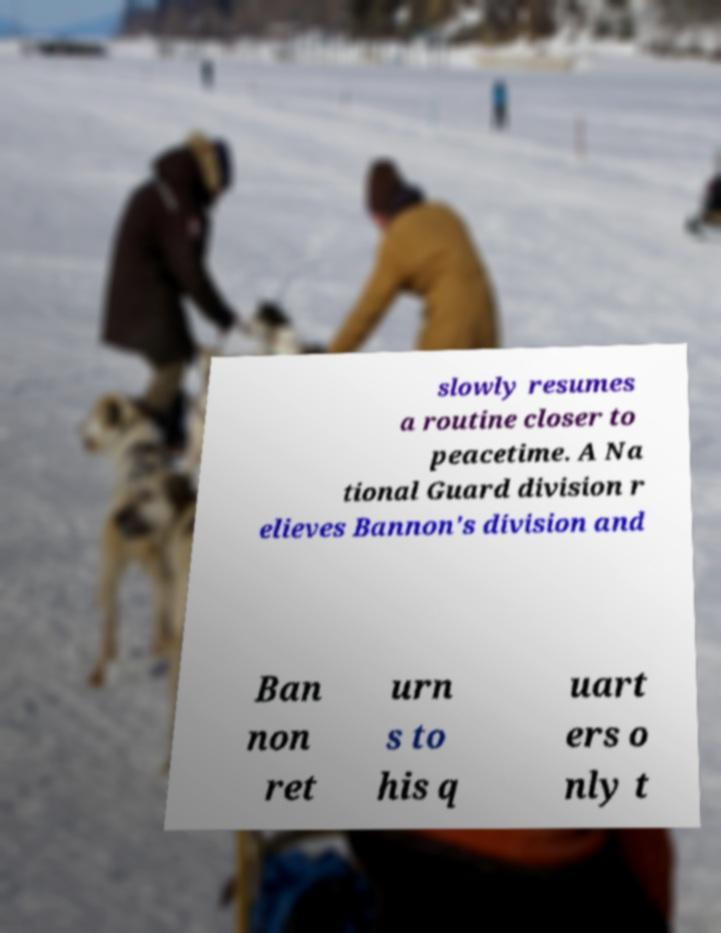There's text embedded in this image that I need extracted. Can you transcribe it verbatim? slowly resumes a routine closer to peacetime. A Na tional Guard division r elieves Bannon's division and Ban non ret urn s to his q uart ers o nly t 